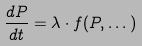<formula> <loc_0><loc_0><loc_500><loc_500>\frac { d P } { d t } = \lambda \cdot f ( P , \dots )</formula> 